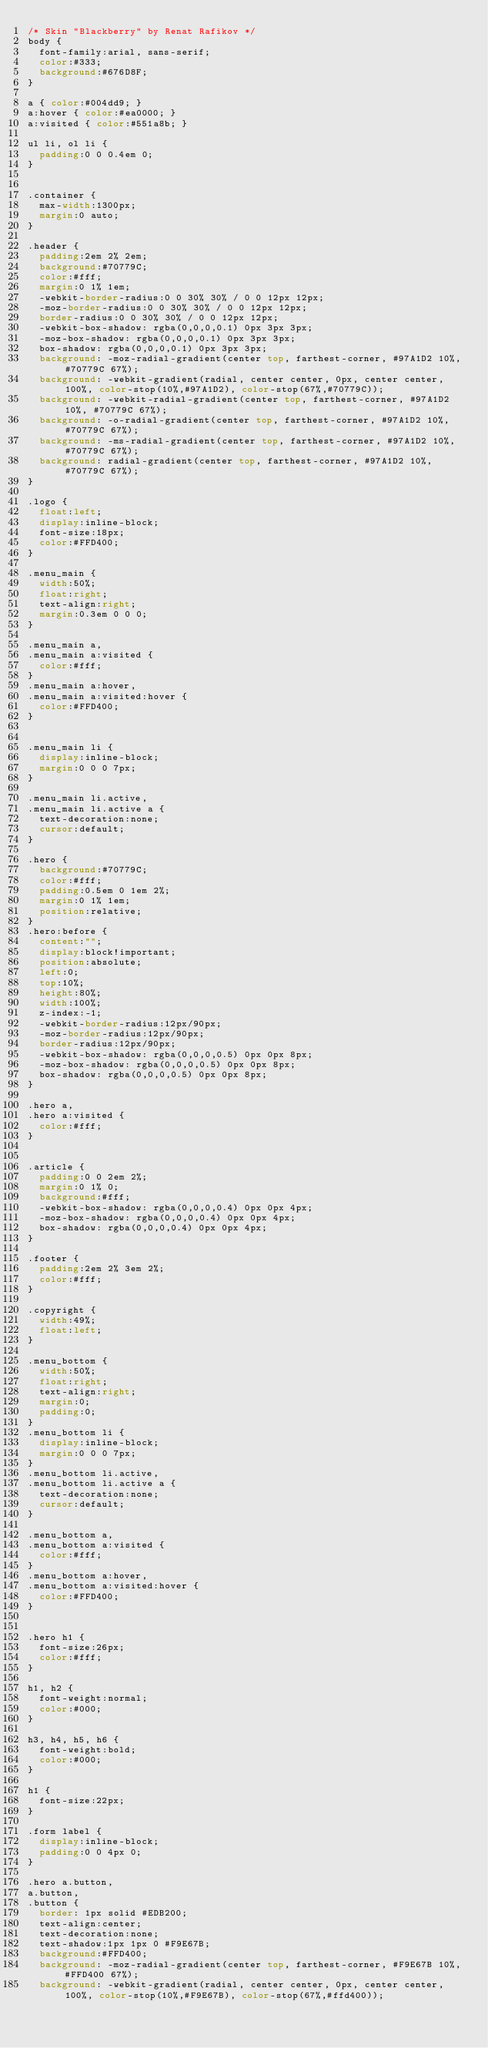Convert code to text. <code><loc_0><loc_0><loc_500><loc_500><_CSS_>/* Skin "Blackberry" by Renat Rafikov */
body {
  font-family:arial, sans-serif;
  color:#333;
  background:#676D8F;
}

a { color:#004dd9; }
a:hover { color:#ea0000; }
a:visited { color:#551a8b; }

ul li, ol li {
  padding:0 0 0.4em 0;
}


.container {
  max-width:1300px;
  margin:0 auto;
}

.header {
  padding:2em 2% 2em;
  background:#70779C;
  color:#fff;
  margin:0 1% 1em;  
  -webkit-border-radius:0 0 30% 30% / 0 0 12px 12px;
  -moz-border-radius:0 0 30% 30% / 0 0 12px 12px;
  border-radius:0 0 30% 30% / 0 0 12px 12px;
  -webkit-box-shadow: rgba(0,0,0,0.1) 0px 3px 3px;
  -moz-box-shadow: rgba(0,0,0,0.1) 0px 3px 3px;
  box-shadow: rgba(0,0,0,0.1) 0px 3px 3px;  
  background: -moz-radial-gradient(center top, farthest-corner, #97A1D2 10%, #70779C 67%);
  background: -webkit-gradient(radial, center center, 0px, center center, 100%, color-stop(10%,#97A1D2), color-stop(67%,#70779C));
  background: -webkit-radial-gradient(center top, farthest-corner, #97A1D2 10%, #70779C 67%);
  background: -o-radial-gradient(center top, farthest-corner, #97A1D2 10%, #70779C 67%);
  background: -ms-radial-gradient(center top, farthest-corner, #97A1D2 10%, #70779C 67%);
  background: radial-gradient(center top, farthest-corner, #97A1D2 10%, #70779C 67%); 
}

.logo {
  float:left;
  display:inline-block;
  font-size:18px;
  color:#FFD400;
}

.menu_main {
  width:50%;
  float:right;
  text-align:right;
  margin:0.3em 0 0 0;
}

.menu_main a,
.menu_main a:visited {
  color:#fff;
}
.menu_main a:hover,
.menu_main a:visited:hover {
  color:#FFD400;
}


.menu_main li {
  display:inline-block;
  margin:0 0 0 7px;
}

.menu_main li.active,
.menu_main li.active a {
  text-decoration:none;
  cursor:default;
}

.hero {
  background:#70779C;
  color:#fff;
  padding:0.5em 0 1em 2%;
  margin:0 1% 1em;
  position:relative;
}
.hero:before {
  content:"";
  display:block!important;
  position:absolute;
  left:0;
  top:10%;
  height:80%;
  width:100%;
  z-index:-1;
  -webkit-border-radius:12px/90px;
  -moz-border-radius:12px/90px;
  border-radius:12px/90px;
  -webkit-box-shadow: rgba(0,0,0,0.5) 0px 0px 8px;
  -moz-box-shadow: rgba(0,0,0,0.5) 0px 0px 8px;
  box-shadow: rgba(0,0,0,0.5) 0px 0px 8px;
}

.hero a,
.hero a:visited {
  color:#fff;
}


.article {
  padding:0 0 2em 2%;
  margin:0 1% 0;
  background:#fff;
  -webkit-box-shadow: rgba(0,0,0,0.4) 0px 0px 4px;
  -moz-box-shadow: rgba(0,0,0,0.4) 0px 0px 4px;
  box-shadow: rgba(0,0,0,0.4) 0px 0px 4px;
}

.footer {
  padding:2em 2% 3em 2%;
  color:#fff;
}

.copyright {
  width:49%;
  float:left;
}

.menu_bottom {
  width:50%;
  float:right;
  text-align:right;
  margin:0;
  padding:0;
}
.menu_bottom li {
  display:inline-block;
  margin:0 0 0 7px;
}
.menu_bottom li.active,
.menu_bottom li.active a {
  text-decoration:none;
  cursor:default;
}

.menu_bottom a,
.menu_bottom a:visited {
  color:#fff;
}
.menu_bottom a:hover,
.menu_bottom a:visited:hover {
  color:#FFD400;
}


.hero h1 {
  font-size:26px;
  color:#fff;
}

h1, h2 {
  font-weight:normal;
  color:#000;
}

h3, h4, h5, h6 {
  font-weight:bold;
  color:#000;
}

h1 {
  font-size:22px;
}

.form label {
  display:inline-block;
  padding:0 0 4px 0;
}

.hero a.button,
a.button,
.button {
  border: 1px solid #EDB200;
  text-align:center; 
  text-decoration:none;
  text-shadow:1px 1px 0 #F9E67B;
  background:#FFD400;  
  background: -moz-radial-gradient(center top, farthest-corner, #F9E67B 10%, #FFD400 67%);
  background: -webkit-gradient(radial, center center, 0px, center center, 100%, color-stop(10%,#F9E67B), color-stop(67%,#ffd400));</code> 